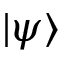Convert formula to latex. <formula><loc_0><loc_0><loc_500><loc_500>| \psi \rangle</formula> 